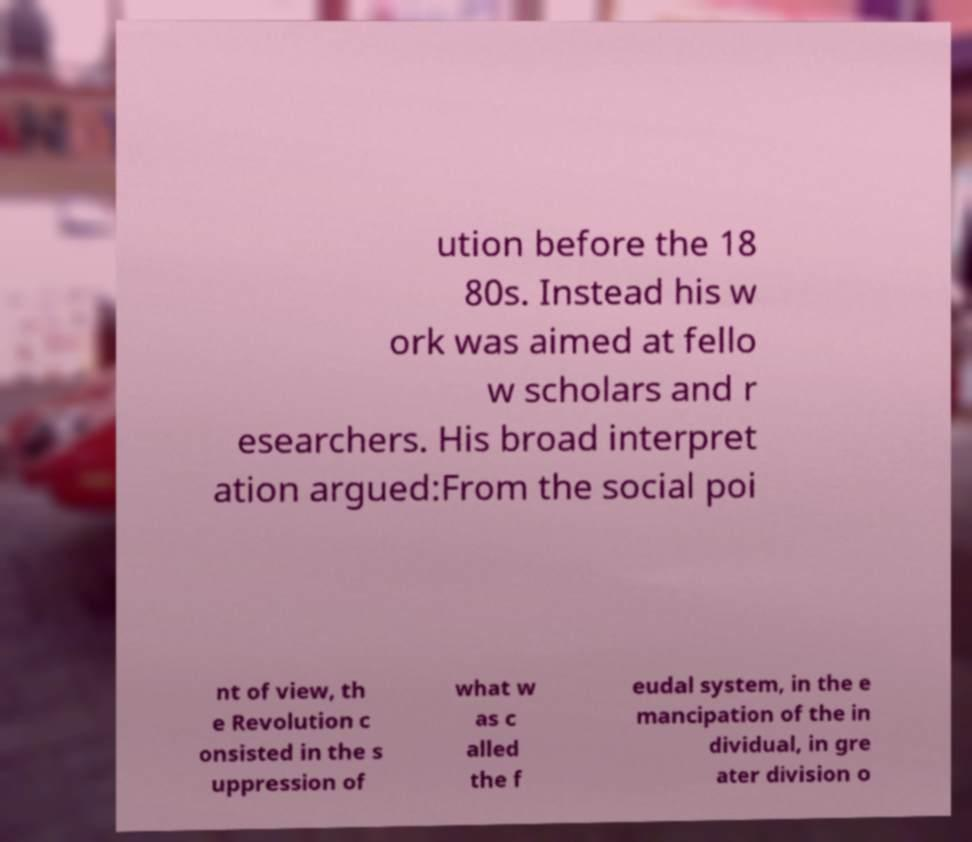I need the written content from this picture converted into text. Can you do that? ution before the 18 80s. Instead his w ork was aimed at fello w scholars and r esearchers. His broad interpret ation argued:From the social poi nt of view, th e Revolution c onsisted in the s uppression of what w as c alled the f eudal system, in the e mancipation of the in dividual, in gre ater division o 